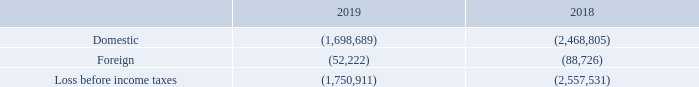NOTE 11 – INCOME TAXES
The components of loss before income taxes are as follows:
What is the company's domestic loss before income tax in 2019? 1,698,689. What is the company's domestic loss before income tax in 2018? 2,468,805. What is the company's foreign loss before income tax in 2019? 52,222. What is the company's percentage change in foreign loss between 2018 and 2019?
Answer scale should be: percent. (52,222 - 88,726)/88,726 
Answer: -41.14. What is the change in the total loss before income taxes between 2018 and 2019? 1,750,911 - 2,557,531 
Answer: -806620. What is the change in the domestic losses between 2018 and 2019? 1,698,689 - 2,468,805 
Answer: -770116. 